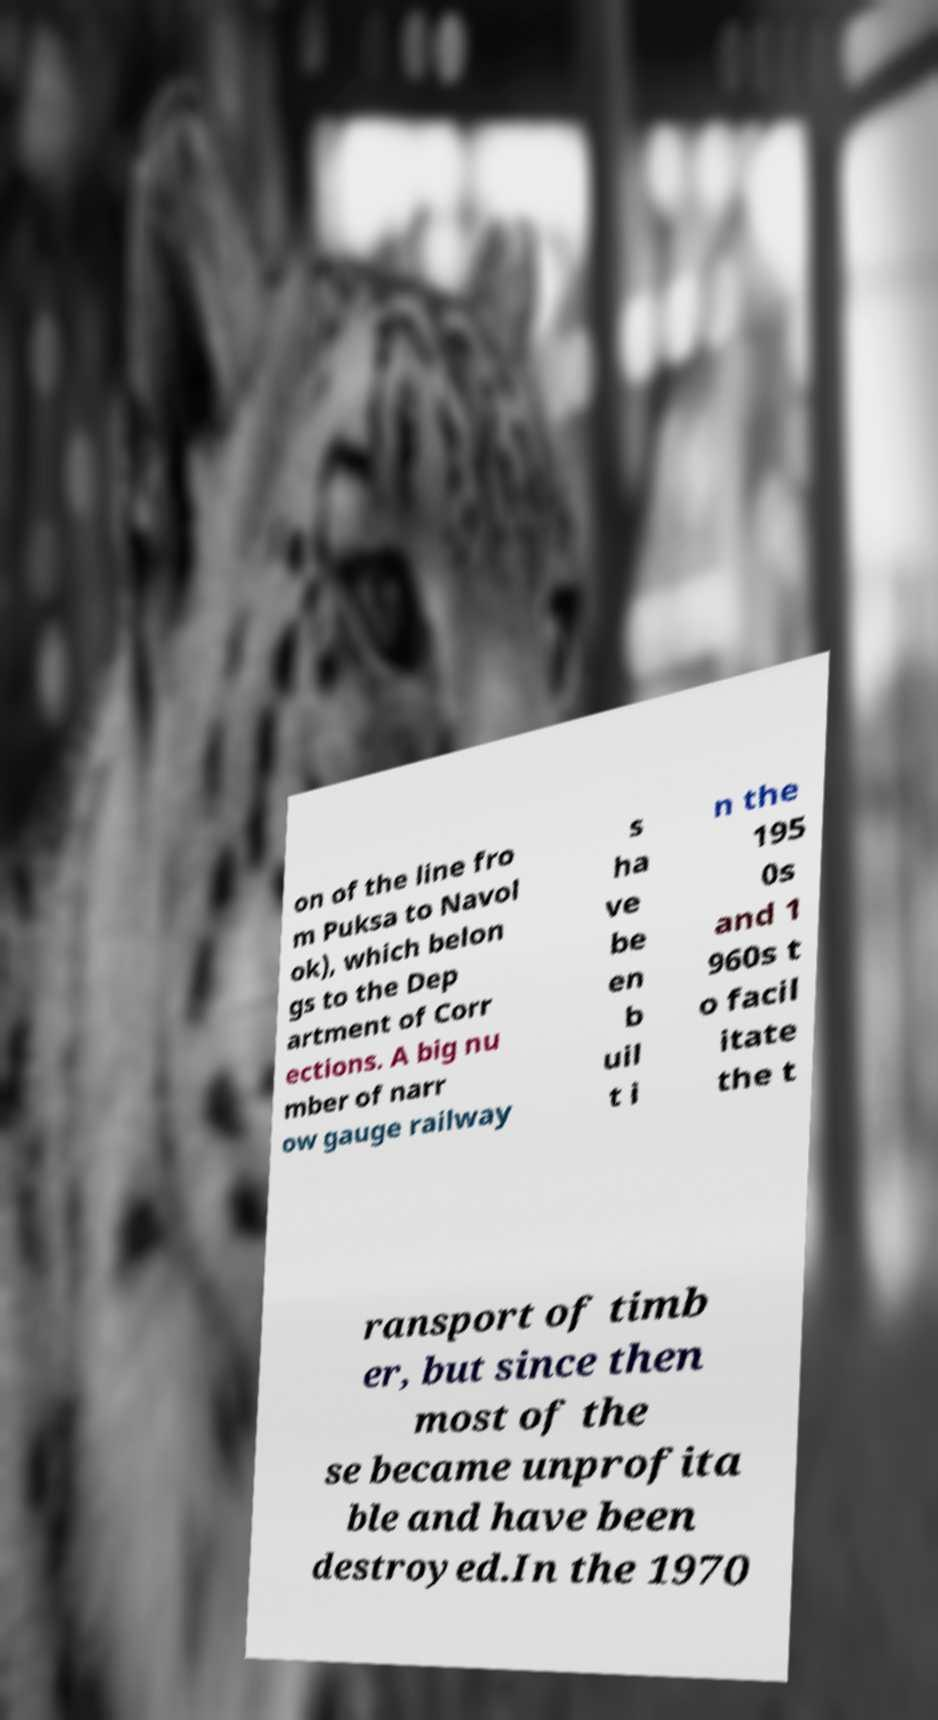Could you assist in decoding the text presented in this image and type it out clearly? on of the line fro m Puksa to Navol ok), which belon gs to the Dep artment of Corr ections. A big nu mber of narr ow gauge railway s ha ve be en b uil t i n the 195 0s and 1 960s t o facil itate the t ransport of timb er, but since then most of the se became unprofita ble and have been destroyed.In the 1970 